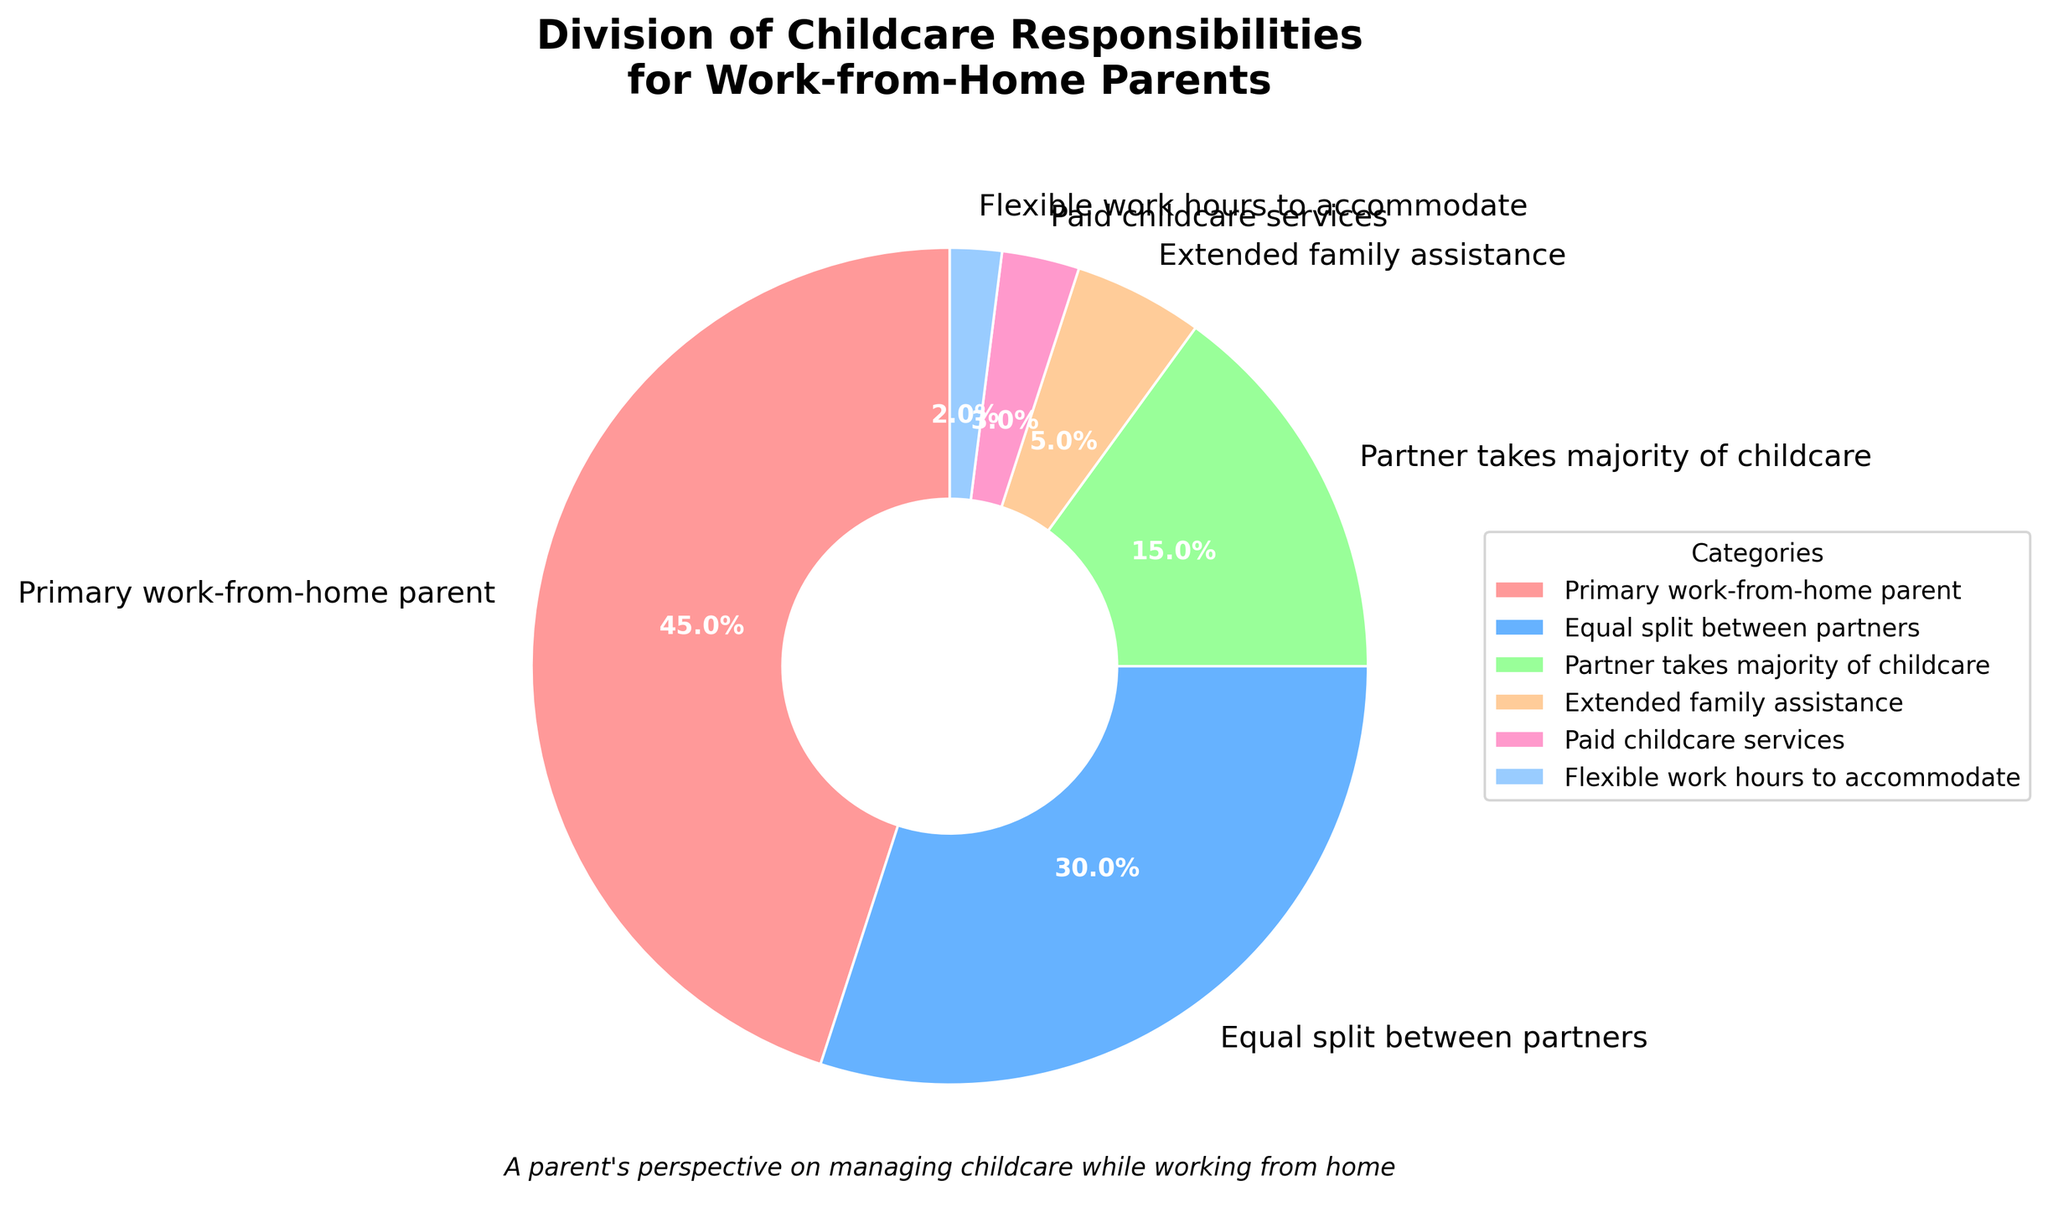What percentage of childcare responsibilities is accounted for by primary work-from-home parents and extended family assistance combined? To find the combined percentage, add the percentages for "Primary work-from-home parent" (45%) and "Extended family assistance" (5%). 45% + 5% = 50%
Answer: 50% Which category has the highest percentage of childcare responsibilities? Look for the category with the largest segment in the pie chart. "Primary work-from-home parent" has the highest percentage at 45%
Answer: Primary work-from-home parent What is the difference in percentage between equal split between partners and partner taking majority of childcare? Subtract the percentage of "Partner takes majority of childcare" (15%) from "Equal split between partners" (30%). 30% - 15% = 15%
Answer: 15% Which category is represented by the largest red-colored segment in the pie chart? Observe the pie chart and identify the category denoted by the largest red-colored segment. The "Primary work-from-home parent" category is depicted in red and has the largest segment
Answer: Primary work-from-home parent How many categories have a percentage of 5% or less? Count the segments that are 5% or less. "Extended family assistance" (5%), "Paid childcare services" (3%), and "Flexible work hours to accommodate" (2%) make 3 categories
Answer: 3 Rank the categories from highest to lowest percentage of childcare responsibilities. List the categories in descending order according to their percentage: "Primary work-from-home parent" (45%), "Equal split between partners" (30%), "Partner takes majority of childcare" (15%), "Extended family assistance" (5%), "Paid childcare services" (3%), "Flexible work hours to accommodate" (2%)
Answer: Primary work-from-home parent, Equal split between partners, Partner takes majority of childcare, Extended family assistance, Paid childcare services, Flexible work hours to accommodate 